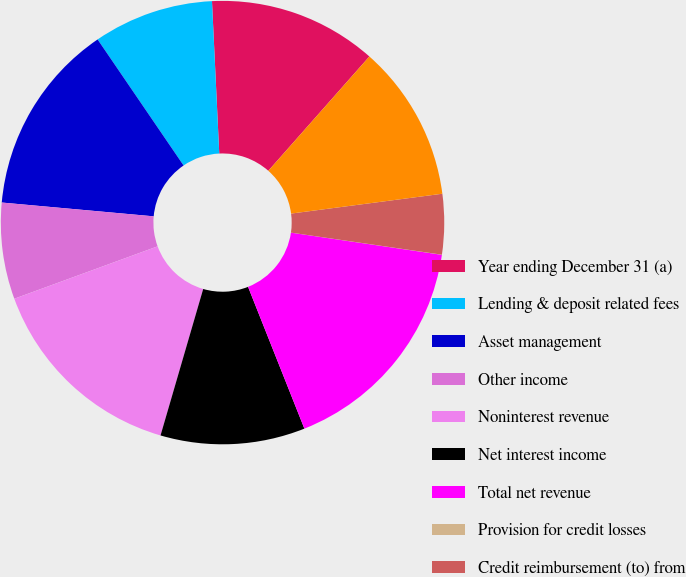<chart> <loc_0><loc_0><loc_500><loc_500><pie_chart><fcel>Year ending December 31 (a)<fcel>Lending & deposit related fees<fcel>Asset management<fcel>Other income<fcel>Noninterest revenue<fcel>Net interest income<fcel>Total net revenue<fcel>Provision for credit losses<fcel>Credit reimbursement (to) from<fcel>Compensation expense<nl><fcel>12.28%<fcel>8.77%<fcel>14.03%<fcel>7.02%<fcel>14.91%<fcel>10.53%<fcel>16.66%<fcel>0.01%<fcel>4.39%<fcel>11.4%<nl></chart> 